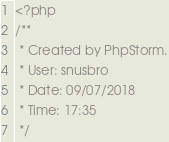Convert code to text. <code><loc_0><loc_0><loc_500><loc_500><_PHP_><?php
/**
 * Created by PhpStorm.
 * User: snusbro
 * Date: 09/07/2018
 * Time: 17:35
 */</code> 